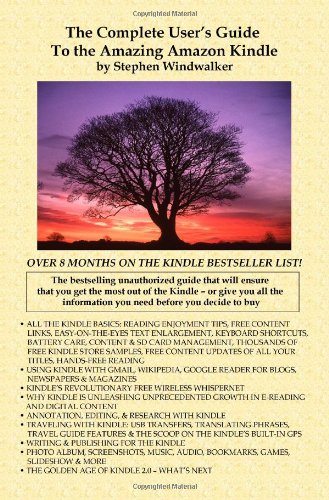What is the title of this book? The title of the book shown in the image is 'The Complete User's Guide to the Amazing Amazon Kindle (First Generation)', a detailed guide about the first generation Amazon Kindle. 